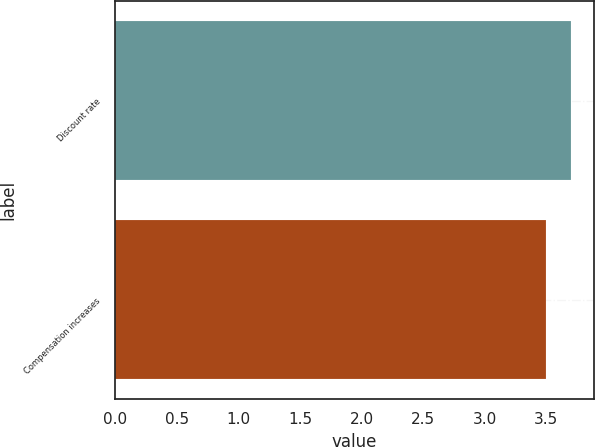<chart> <loc_0><loc_0><loc_500><loc_500><bar_chart><fcel>Discount rate<fcel>Compensation increases<nl><fcel>3.7<fcel>3.5<nl></chart> 